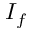Convert formula to latex. <formula><loc_0><loc_0><loc_500><loc_500>I _ { f }</formula> 